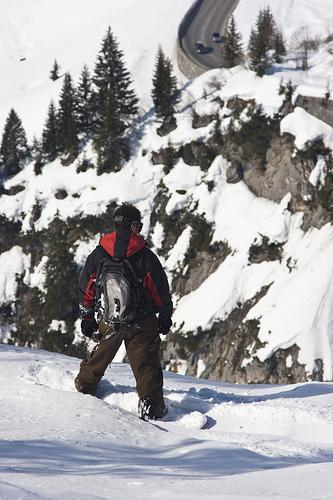What is near the trees?

Choices:
A) wolves
B) hyenas
C) beavers
D) snow snow 